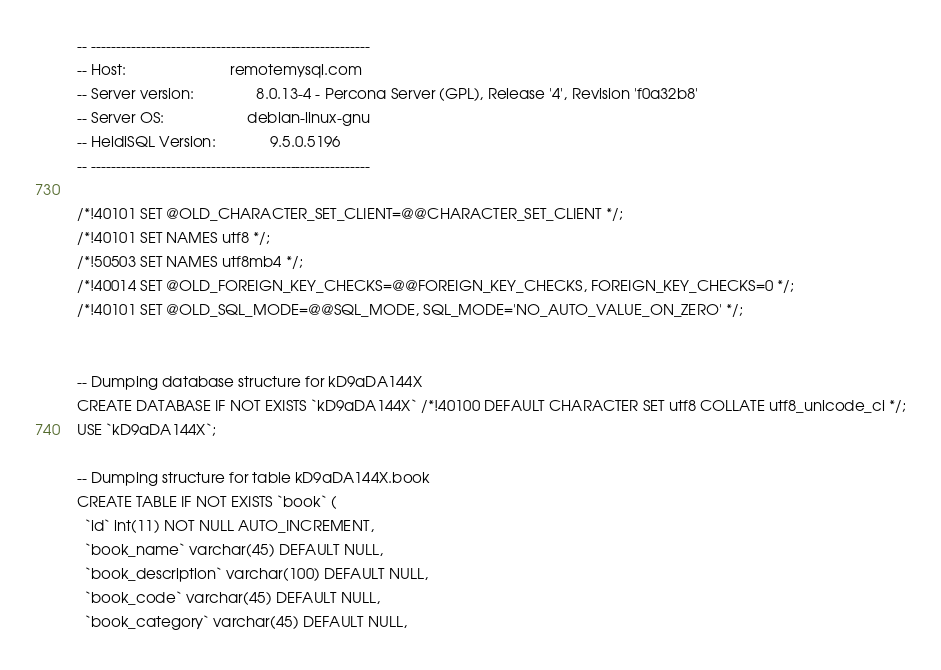<code> <loc_0><loc_0><loc_500><loc_500><_SQL_>-- --------------------------------------------------------
-- Host:                         remotemysql.com
-- Server version:               8.0.13-4 - Percona Server (GPL), Release '4', Revision 'f0a32b8'
-- Server OS:                    debian-linux-gnu
-- HeidiSQL Version:             9.5.0.5196
-- --------------------------------------------------------

/*!40101 SET @OLD_CHARACTER_SET_CLIENT=@@CHARACTER_SET_CLIENT */;
/*!40101 SET NAMES utf8 */;
/*!50503 SET NAMES utf8mb4 */;
/*!40014 SET @OLD_FOREIGN_KEY_CHECKS=@@FOREIGN_KEY_CHECKS, FOREIGN_KEY_CHECKS=0 */;
/*!40101 SET @OLD_SQL_MODE=@@SQL_MODE, SQL_MODE='NO_AUTO_VALUE_ON_ZERO' */;


-- Dumping database structure for kD9aDA144X
CREATE DATABASE IF NOT EXISTS `kD9aDA144X` /*!40100 DEFAULT CHARACTER SET utf8 COLLATE utf8_unicode_ci */;
USE `kD9aDA144X`;

-- Dumping structure for table kD9aDA144X.book
CREATE TABLE IF NOT EXISTS `book` (
  `id` int(11) NOT NULL AUTO_INCREMENT,
  `book_name` varchar(45) DEFAULT NULL,
  `book_description` varchar(100) DEFAULT NULL,
  `book_code` varchar(45) DEFAULT NULL,
  `book_category` varchar(45) DEFAULT NULL,</code> 